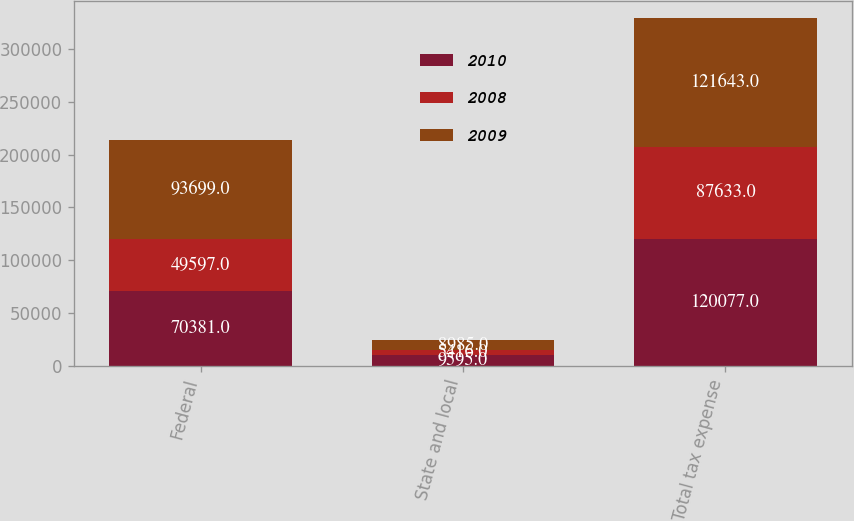Convert chart. <chart><loc_0><loc_0><loc_500><loc_500><stacked_bar_chart><ecel><fcel>Federal<fcel>State and local<fcel>Total tax expense<nl><fcel>2010<fcel>70381<fcel>9595<fcel>120077<nl><fcel>2008<fcel>49597<fcel>5416<fcel>87633<nl><fcel>2009<fcel>93699<fcel>8985<fcel>121643<nl></chart> 